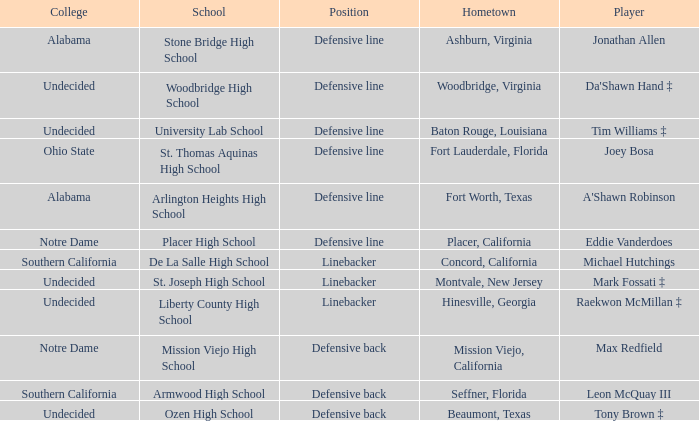What position did Max Redfield play? Defensive back. 